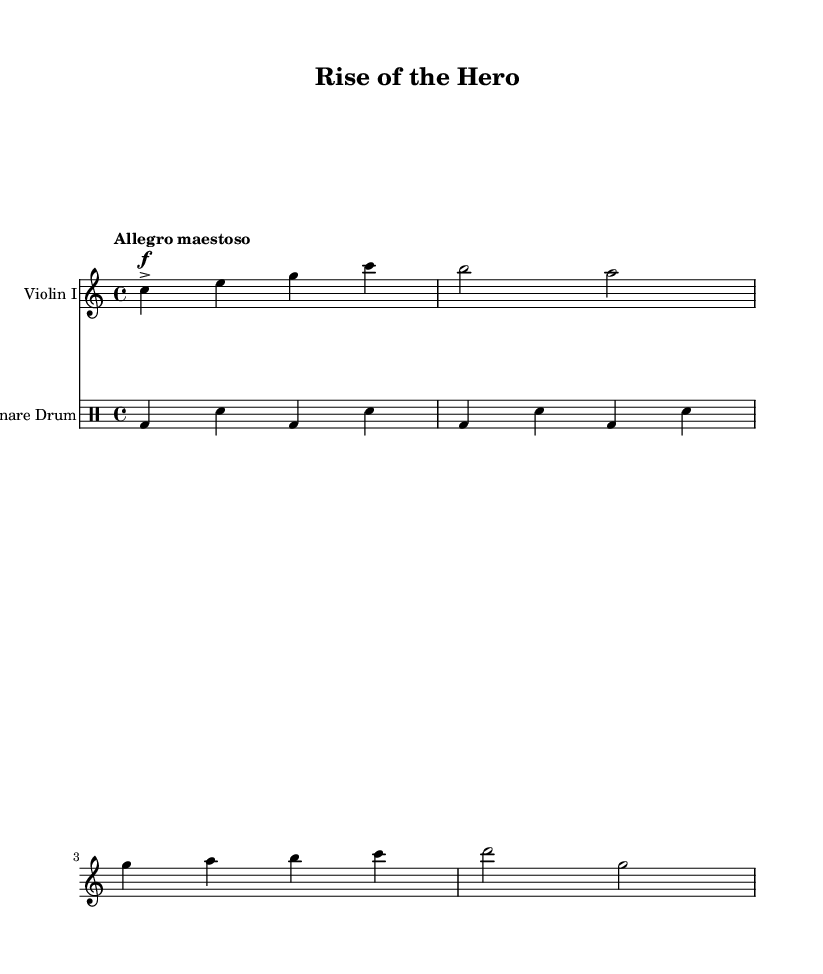What is the time signature of this music? The time signature appears at the beginning of the score and is indicated as 4/4, meaning there are four beats in each measure and the quarter note gets one beat.
Answer: 4/4 What is the key signature of this music? The key signature is deduced from the absence of any sharps or flats at the beginning of the staff, indicating that it is in C major.
Answer: C major What is the tempo marking indicated? The tempo marking is specified as "Allegro maestoso," suggesting a fast-paced and majestic style of play.
Answer: Allegro maestoso How many measures are present in the violin part? By counting the distinct groupings of notes separated by vertical lines (bar lines) in the violin part, we find a total of four measures.
Answer: 4 What instrument is indicated to play the snare part? The instrument name is explicitly stated at the start of the drum staff, showing that the snare drum is the instrument written for this part.
Answer: Snare drum What dynamics are marked in the violin part? The violin part has a dynamic marking of "f" which is an abbreviation for 'forte,' meaning to play loudly, and is accentuated, indicated by the accent symbol.
Answer: forte 